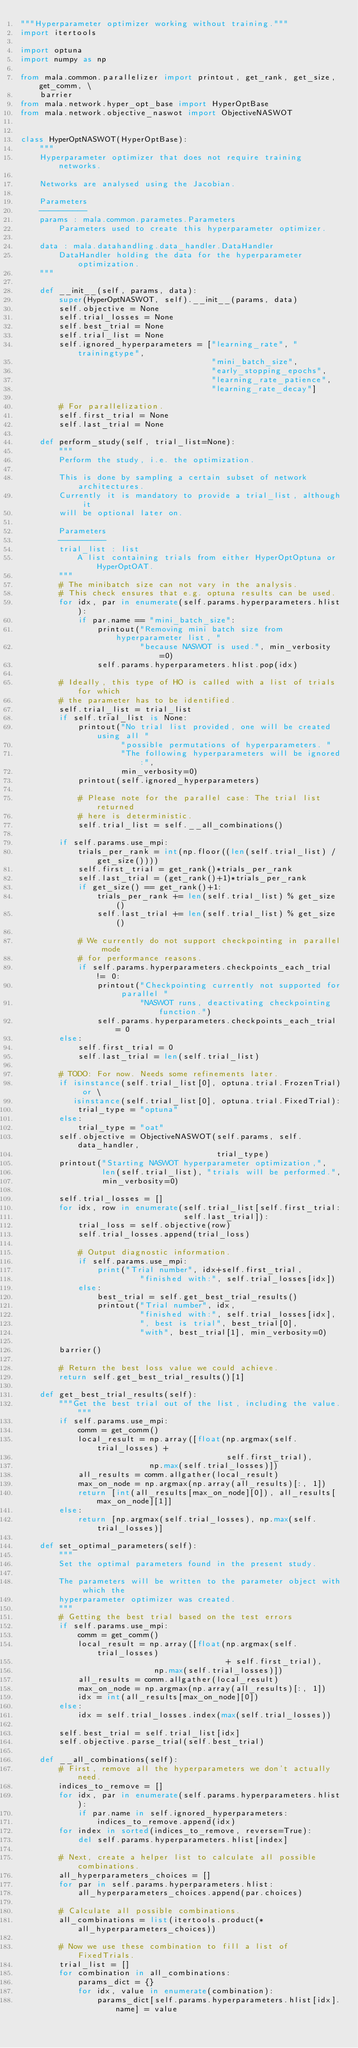Convert code to text. <code><loc_0><loc_0><loc_500><loc_500><_Python_>"""Hyperparameter optimizer working without training."""
import itertools

import optuna
import numpy as np

from mala.common.parallelizer import printout, get_rank, get_size, get_comm, \
    barrier
from mala.network.hyper_opt_base import HyperOptBase
from mala.network.objective_naswot import ObjectiveNASWOT


class HyperOptNASWOT(HyperOptBase):
    """
    Hyperparameter optimizer that does not require training networks.

    Networks are analysed using the Jacobian.

    Parameters
    ----------
    params : mala.common.parametes.Parameters
        Parameters used to create this hyperparameter optimizer.

    data : mala.datahandling.data_handler.DataHandler
        DataHandler holding the data for the hyperparameter optimization.
    """

    def __init__(self, params, data):
        super(HyperOptNASWOT, self).__init__(params, data)
        self.objective = None
        self.trial_losses = None
        self.best_trial = None
        self.trial_list = None
        self.ignored_hyperparameters = ["learning_rate", "trainingtype",
                                        "mini_batch_size",
                                        "early_stopping_epochs",
                                        "learning_rate_patience",
                                        "learning_rate_decay"]

        # For parallelization.
        self.first_trial = None
        self.last_trial = None

    def perform_study(self, trial_list=None):
        """
        Perform the study, i.e. the optimization.

        This is done by sampling a certain subset of network architectures.
        Currently it is mandatory to provide a trial_list, although it
        will be optional later on.

        Parameters
        ----------
        trial_list : list
            A list containing trials from either HyperOptOptuna or HyperOptOAT.
        """
        # The minibatch size can not vary in the analysis.
        # This check ensures that e.g. optuna results can be used.
        for idx, par in enumerate(self.params.hyperparameters.hlist):
            if par.name == "mini_batch_size":
                printout("Removing mini batch size from hyperparameter list, "
                         "because NASWOT is used.", min_verbosity=0)
                self.params.hyperparameters.hlist.pop(idx)

        # Ideally, this type of HO is called with a list of trials for which
        # the parameter has to be identified.
        self.trial_list = trial_list
        if self.trial_list is None:
            printout("No trial list provided, one will be created using all "
                     "possible permutations of hyperparameters. "
                     "The following hyperparameters will be ignored:",
                     min_verbosity=0)
            printout(self.ignored_hyperparameters)

            # Please note for the parallel case: The trial list returned
            # here is deterministic.
            self.trial_list = self.__all_combinations()

        if self.params.use_mpi:
            trials_per_rank = int(np.floor((len(self.trial_list) / get_size())))
            self.first_trial = get_rank()*trials_per_rank
            self.last_trial = (get_rank()+1)*trials_per_rank
            if get_size() == get_rank()+1:
                trials_per_rank += len(self.trial_list) % get_size()
                self.last_trial += len(self.trial_list) % get_size()

            # We currently do not support checkpointing in parallel mode
            # for performance reasons.
            if self.params.hyperparameters.checkpoints_each_trial != 0:
                printout("Checkpointing currently not supported for parallel "
                         "NASWOT runs, deactivating checkpointing function.")
                self.params.hyperparameters.checkpoints_each_trial = 0
        else:
            self.first_trial = 0
            self.last_trial = len(self.trial_list)

        # TODO: For now. Needs some refinements later.
        if isinstance(self.trial_list[0], optuna.trial.FrozenTrial) or \
           isinstance(self.trial_list[0], optuna.trial.FixedTrial):
            trial_type = "optuna"
        else:
            trial_type = "oat"
        self.objective = ObjectiveNASWOT(self.params, self.data_handler,
                                         trial_type)
        printout("Starting NASWOT hyperparameter optimization,",
                 len(self.trial_list), "trials will be performed.",
                 min_verbosity=0)

        self.trial_losses = []
        for idx, row in enumerate(self.trial_list[self.first_trial:
                                  self.last_trial]):
            trial_loss = self.objective(row)
            self.trial_losses.append(trial_loss)

            # Output diagnostic information.
            if self.params.use_mpi:
                print("Trial number", idx+self.first_trial,
                         "finished with:", self.trial_losses[idx])
            else:
                best_trial = self.get_best_trial_results()
                printout("Trial number", idx,
                         "finished with:", self.trial_losses[idx],
                         ", best is trial", best_trial[0],
                         "with", best_trial[1], min_verbosity=0)

        barrier()

        # Return the best loss value we could achieve.
        return self.get_best_trial_results()[1]

    def get_best_trial_results(self):
        """Get the best trial out of the list, including the value."""
        if self.params.use_mpi:
            comm = get_comm()
            local_result = np.array([float(np.argmax(self.trial_losses) +
                                           self.first_trial),
                           np.max(self.trial_losses)])
            all_results = comm.allgather(local_result)
            max_on_node = np.argmax(np.array(all_results)[:, 1])
            return [int(all_results[max_on_node][0]), all_results[max_on_node][1]]
        else:
            return [np.argmax(self.trial_losses), np.max(self.trial_losses)]

    def set_optimal_parameters(self):
        """
        Set the optimal parameters found in the present study.

        The parameters will be written to the parameter object with which the
        hyperparameter optimizer was created.
        """
        # Getting the best trial based on the test errors
        if self.params.use_mpi:
            comm = get_comm()
            local_result = np.array([float(np.argmax(self.trial_losses)
                                           + self.first_trial),
                            np.max(self.trial_losses)])
            all_results = comm.allgather(local_result)
            max_on_node = np.argmax(np.array(all_results)[:, 1])
            idx = int(all_results[max_on_node][0])
        else:
            idx = self.trial_losses.index(max(self.trial_losses))

        self.best_trial = self.trial_list[idx]
        self.objective.parse_trial(self.best_trial)

    def __all_combinations(self):
        # First, remove all the hyperparameters we don't actually need.
        indices_to_remove = []
        for idx, par in enumerate(self.params.hyperparameters.hlist):
            if par.name in self.ignored_hyperparameters:
                indices_to_remove.append(idx)
        for index in sorted(indices_to_remove, reverse=True):
            del self.params.hyperparameters.hlist[index]

        # Next, create a helper list to calculate all possible combinations.
        all_hyperparameters_choices = []
        for par in self.params.hyperparameters.hlist:
            all_hyperparameters_choices.append(par.choices)

        # Calculate all possible combinations.
        all_combinations = list(itertools.product(*all_hyperparameters_choices))

        # Now we use these combination to fill a list of FixedTrials.
        trial_list = []
        for combination in all_combinations:
            params_dict = {}
            for idx, value in enumerate(combination):
                params_dict[self.params.hyperparameters.hlist[idx].name] = value</code> 